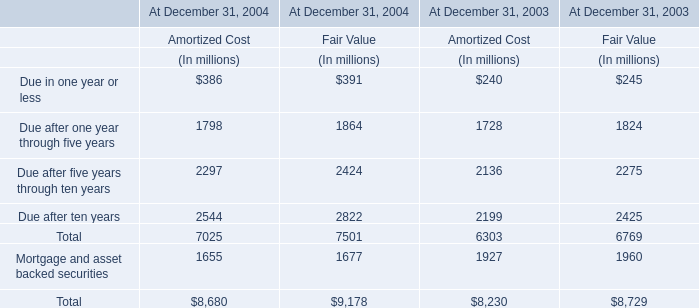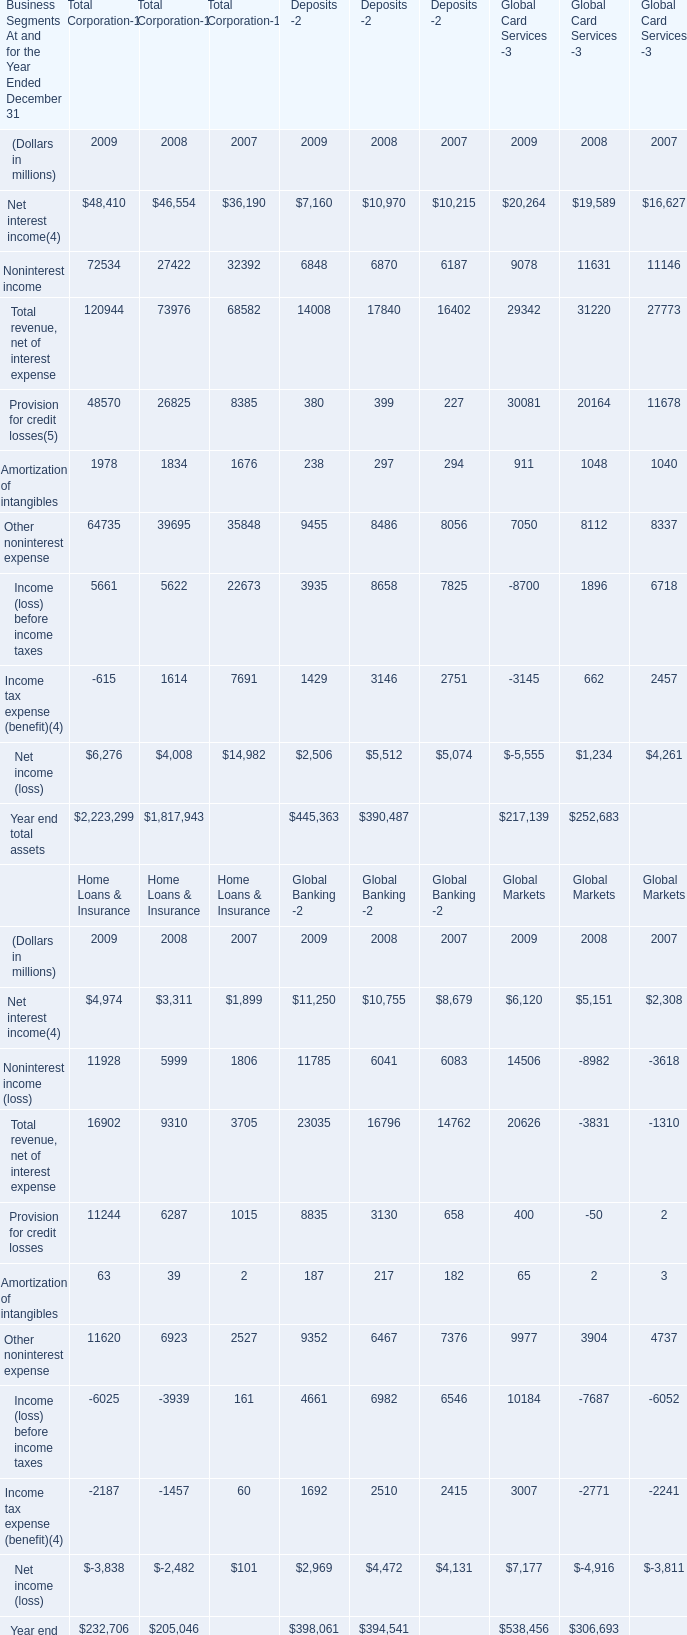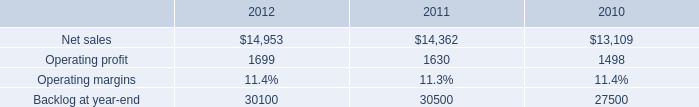What's the sum of Net interest income in 2009? (in million) 
Computations: ((48410 + 7160) + 20264)
Answer: 75834.0. 